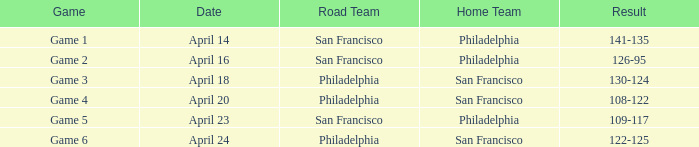Help me parse the entirety of this table. {'header': ['Game', 'Date', 'Road Team', 'Home Team', 'Result'], 'rows': [['Game 1', 'April 14', 'San Francisco', 'Philadelphia', '141-135'], ['Game 2', 'April 16', 'San Francisco', 'Philadelphia', '126-95'], ['Game 3', 'April 18', 'Philadelphia', 'San Francisco', '130-124'], ['Game 4', 'April 20', 'Philadelphia', 'San Francisco', '108-122'], ['Game 5', 'April 23', 'San Francisco', 'Philadelphia', '109-117'], ['Game 6', 'April 24', 'Philadelphia', 'San Francisco', '122-125']]} What was the result of the game played on April 16 with Philadelphia as home team? 126-95. 